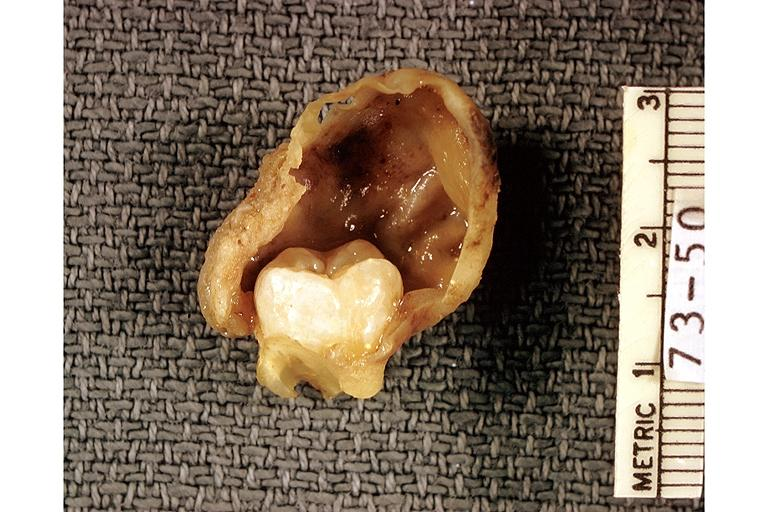s oral present?
Answer the question using a single word or phrase. Yes 